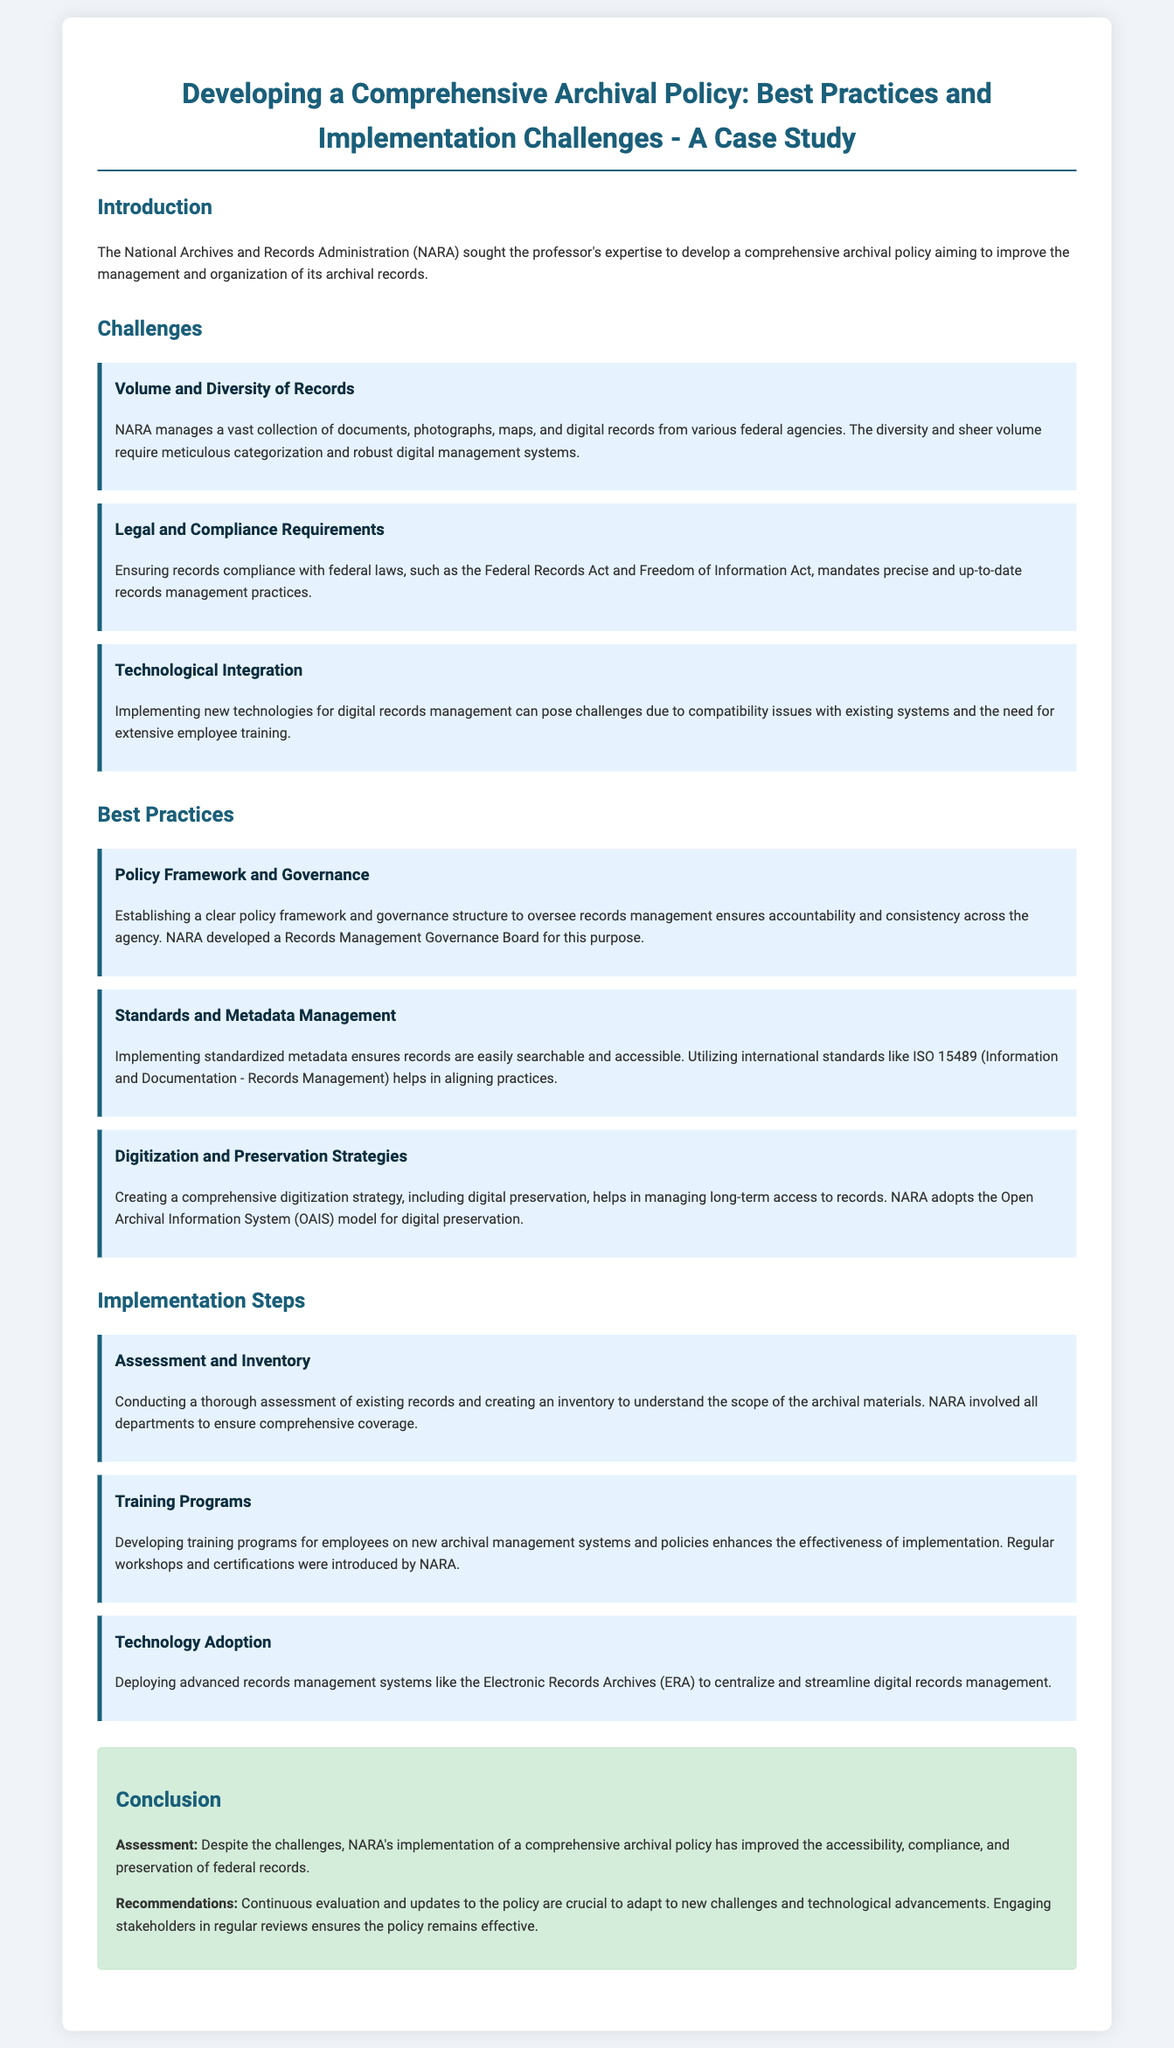What is the main purpose of the case study? The case study aims to develop a comprehensive archival policy to improve the management and organization of its archival records.
Answer: Improve management and organization Who is the archival management authority mentioned in the document? The document states the National Archives and Records Administration is the authority in focus.
Answer: National Archives and Records Administration What challenge involves legal compliance? The challenge of ensuring records compliance with federal laws.
Answer: Legal and Compliance Requirements What is one best practice for records management? Establishing a clear policy framework and governance structure is highlighted as a best practice.
Answer: Policy Framework and Governance Which model does NARA adopt for digital preservation? The document mentions that NARA adopts the Open Archival Information System model.
Answer: Open Archival Information System How many implementation steps are outlined in the case study? The implementation steps section includes three detailed steps.
Answer: Three What type of training programs were introduced? Regular workshops and certifications were introduced to enhance effectiveness.
Answer: Regular workshops and certifications What is a key component for managing long-term access to records? The case study emphasizes creating a comprehensive digitization strategy for long-term access.
Answer: Comprehensive digitization strategy 